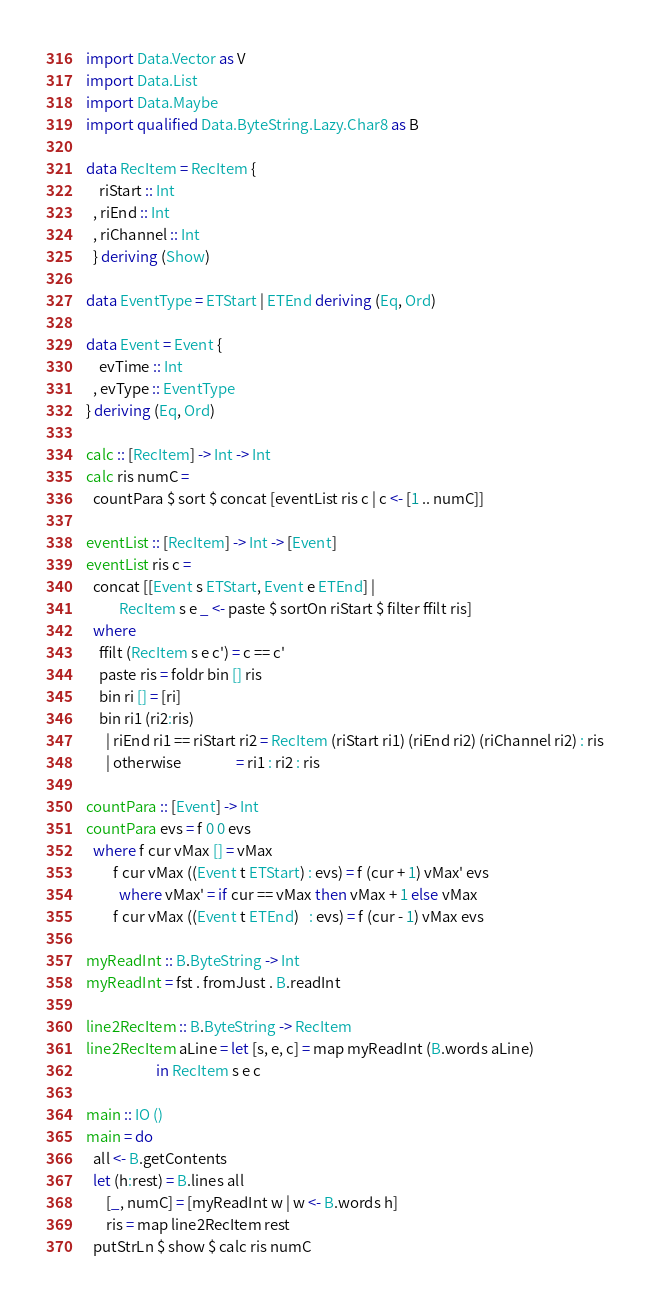<code> <loc_0><loc_0><loc_500><loc_500><_Haskell_>import Data.Vector as V
import Data.List
import Data.Maybe
import qualified Data.ByteString.Lazy.Char8 as B

data RecItem = RecItem {
    riStart :: Int
  , riEnd :: Int
  , riChannel :: Int
  } deriving (Show)

data EventType = ETStart | ETEnd deriving (Eq, Ord)

data Event = Event {
    evTime :: Int
  , evType :: EventType
} deriving (Eq, Ord)

calc :: [RecItem] -> Int -> Int
calc ris numC =
  countPara $ sort $ concat [eventList ris c | c <- [1 .. numC]]

eventList :: [RecItem] -> Int -> [Event]
eventList ris c = 
  concat [[Event s ETStart, Event e ETEnd] |
          RecItem s e _ <- paste $ sortOn riStart $ filter ffilt ris]
  where 
    ffilt (RecItem s e c') = c == c'
    paste ris = foldr bin [] ris
    bin ri [] = [ri]
    bin ri1 (ri2:ris)
      | riEnd ri1 == riStart ri2 = RecItem (riStart ri1) (riEnd ri2) (riChannel ri2) : ris
      | otherwise                = ri1 : ri2 : ris

countPara :: [Event] -> Int
countPara evs = f 0 0 evs
  where f cur vMax [] = vMax
        f cur vMax ((Event t ETStart) : evs) = f (cur + 1) vMax' evs
          where vMax' = if cur == vMax then vMax + 1 else vMax
        f cur vMax ((Event t ETEnd)   : evs) = f (cur - 1) vMax evs

myReadInt :: B.ByteString -> Int
myReadInt = fst . fromJust . B.readInt

line2RecItem :: B.ByteString -> RecItem
line2RecItem aLine = let [s, e, c] = map myReadInt (B.words aLine)
                     in RecItem s e c

main :: IO ()
main = do
  all <- B.getContents
  let (h:rest) = B.lines all
      [_, numC] = [myReadInt w | w <- B.words h]
      ris = map line2RecItem rest
  putStrLn $ show $ calc ris numC

</code> 